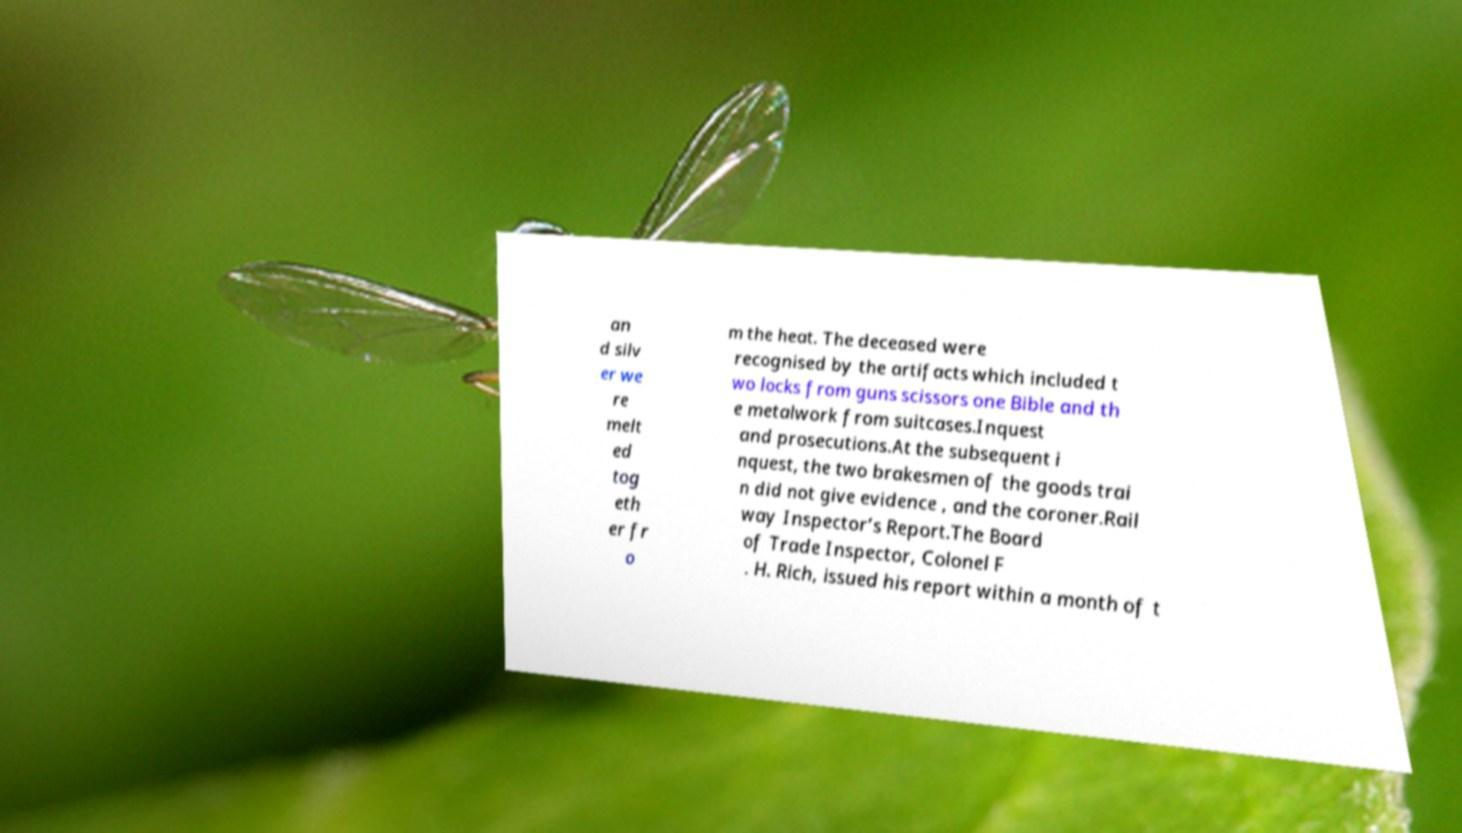Please read and relay the text visible in this image. What does it say? an d silv er we re melt ed tog eth er fr o m the heat. The deceased were recognised by the artifacts which included t wo locks from guns scissors one Bible and th e metalwork from suitcases.Inquest and prosecutions.At the subsequent i nquest, the two brakesmen of the goods trai n did not give evidence , and the coroner.Rail way Inspector’s Report.The Board of Trade Inspector, Colonel F . H. Rich, issued his report within a month of t 